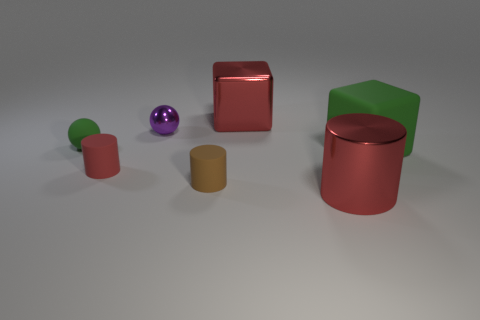What number of metallic cylinders have the same size as the green rubber block?
Ensure brevity in your answer.  1. Is the size of the brown matte object the same as the purple object?
Offer a terse response. Yes. There is a matte thing that is both behind the red matte cylinder and to the right of the tiny green matte object; how big is it?
Offer a very short reply. Large. Are there more small brown rubber cylinders that are to the left of the big green object than spheres that are left of the green ball?
Make the answer very short. Yes. What is the color of the tiny matte thing that is the same shape as the tiny purple shiny thing?
Ensure brevity in your answer.  Green. Is the color of the block behind the big green block the same as the shiny cylinder?
Your response must be concise. Yes. What number of tiny red cylinders are there?
Offer a terse response. 1. Is the big cube that is behind the green rubber ball made of the same material as the green cube?
Ensure brevity in your answer.  No. Are there any other things that are the same material as the big green object?
Provide a succinct answer. Yes. There is a large red thing behind the red cylinder that is left of the brown matte cylinder; how many red metal objects are on the right side of it?
Ensure brevity in your answer.  1. 